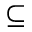<formula> <loc_0><loc_0><loc_500><loc_500>\subseteq</formula> 